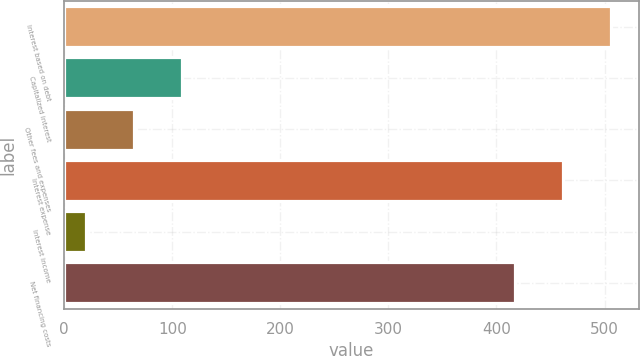Convert chart to OTSL. <chart><loc_0><loc_0><loc_500><loc_500><bar_chart><fcel>Interest based on debt<fcel>Capitalized interest<fcel>Other fees and expenses<fcel>Interest expense<fcel>Interest income<fcel>Net financing costs<nl><fcel>506.2<fcel>109.2<fcel>64.6<fcel>461.6<fcel>20<fcel>417<nl></chart> 